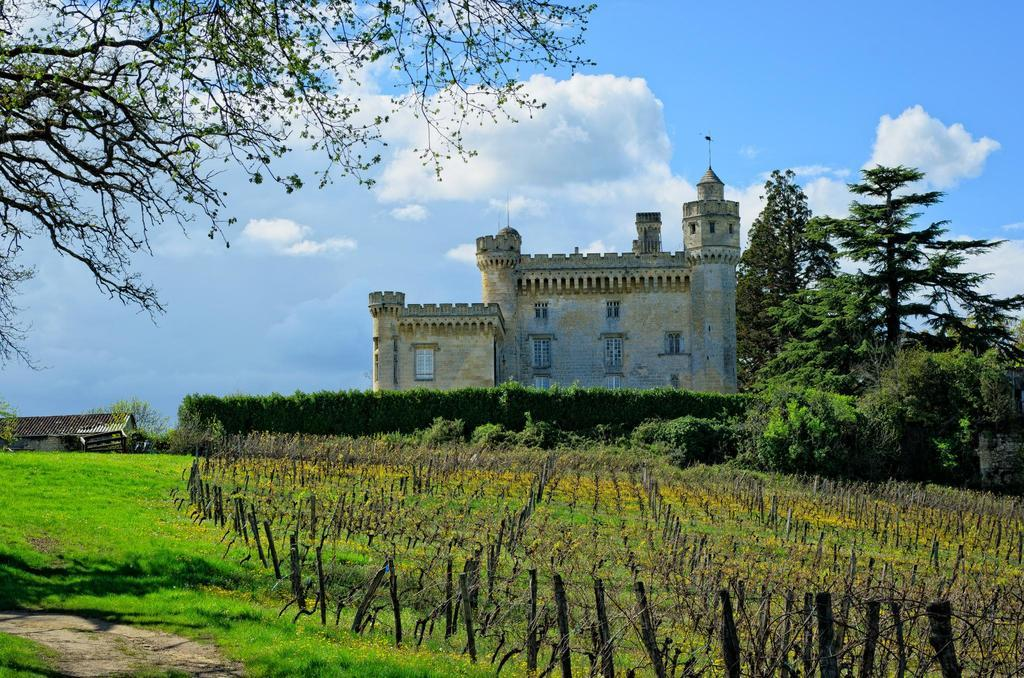What can be seen in the sky in the image? The sky is visible in the image, and clouds are present. What type of vegetation is present in the image? Trees and plants are present in the image, and grass is visible. What structures can be seen in the image? There is a house and a building in the image, and windows are present. How does the steam escape from the quiver in the image? There is no steam or quiver present in the image. What type of power source is used to operate the building in the image? The image does not provide information about the power source for the building. 